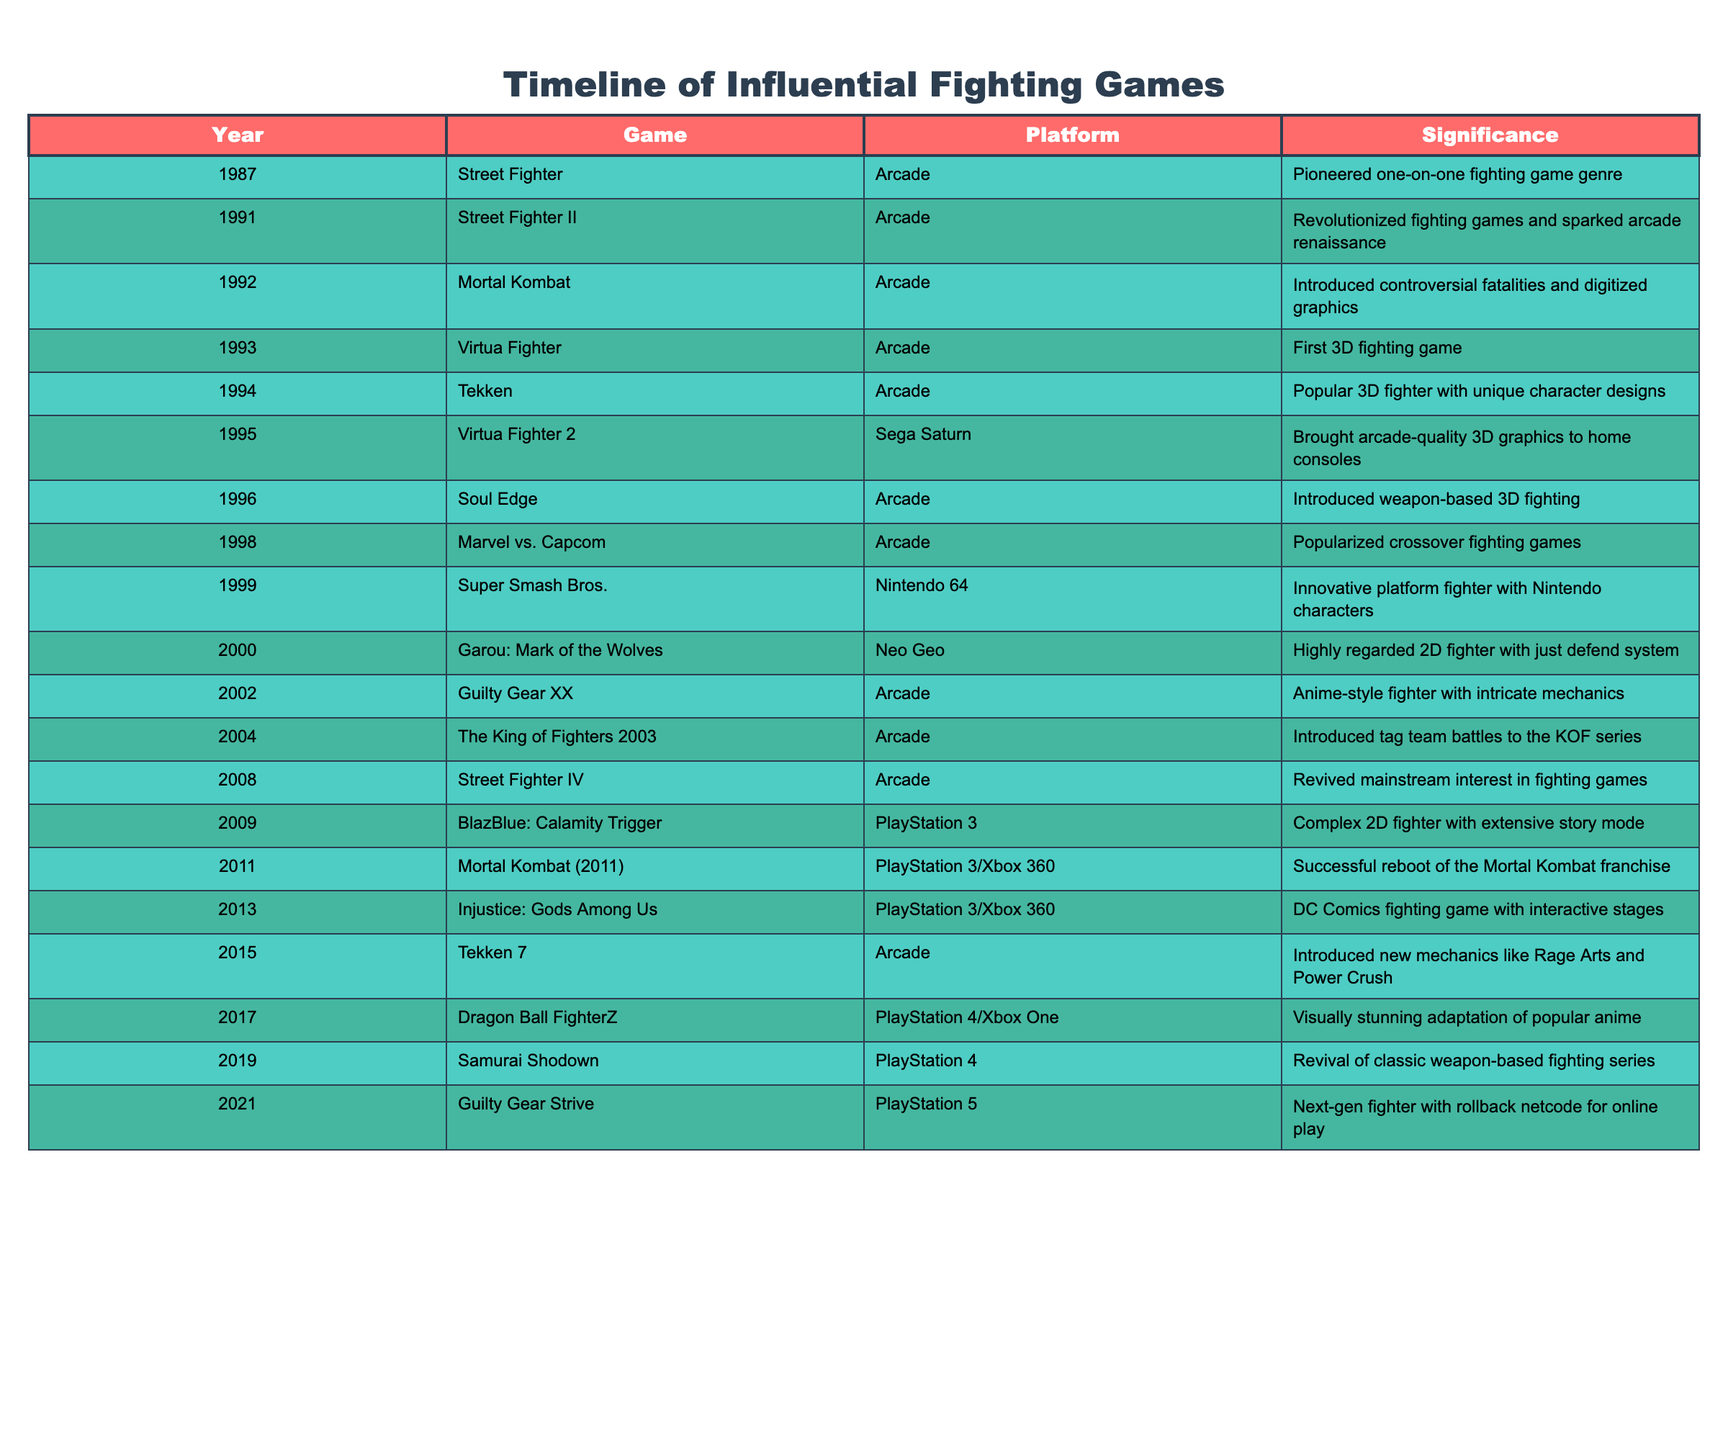What year was Mortal Kombat released? The table shows that the release year for Mortal Kombat is 1992.
Answer: 1992 Which game was the first 3D fighting game? According to the table, Virtua Fighter, released in 1993, is identified as the first 3D fighting game.
Answer: Virtua Fighter How many years passed between the release of Street Fighter II and Soul Edge? From the table, Street Fighter II was released in 1991 and Soul Edge in 1996. Subtracting, we find that 1996 - 1991 = 5 years.
Answer: 5 years Is Tekken 7 the only entry in its series listed in the table? The table features Tekken, released in 1994, and Tekken 7, released in 2015, indicating that there are multiple entries in the Tekken series listed.
Answer: No Which game introduced weapon-based fighting? Soul Edge, released in 1996, is noted in the table as introducing weapon-based fighting.
Answer: Soul Edge What is the significance of Super Smash Bros.? The significance of Super Smash Bros. listed in the table is that it was an innovative platform fighter featuring Nintendo characters.
Answer: Innovative platform fighter with Nintendo characters How many fighting games were released in the 2000s? By reviewing the table, the following games were released in the 2000s: Garou: Mark of the Wolves (2000), Guilty Gear XX (2002), and Mortal Kombat (2011), making a total of 4 fighting games.
Answer: 4 games Which fighting game is the most recent in the table? The most recent game listed in the table is Guilty Gear Strive, released in 2021.
Answer: Guilty Gear Strive Did any of the games on the list receive a reboot? Yes, Mortal Kombat (2011) is identified as a successful reboot of the Mortal Kombat franchise in the table.
Answer: Yes 